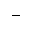Convert formula to latex. <formula><loc_0><loc_0><loc_500><loc_500>-</formula> 